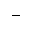Convert formula to latex. <formula><loc_0><loc_0><loc_500><loc_500>-</formula> 